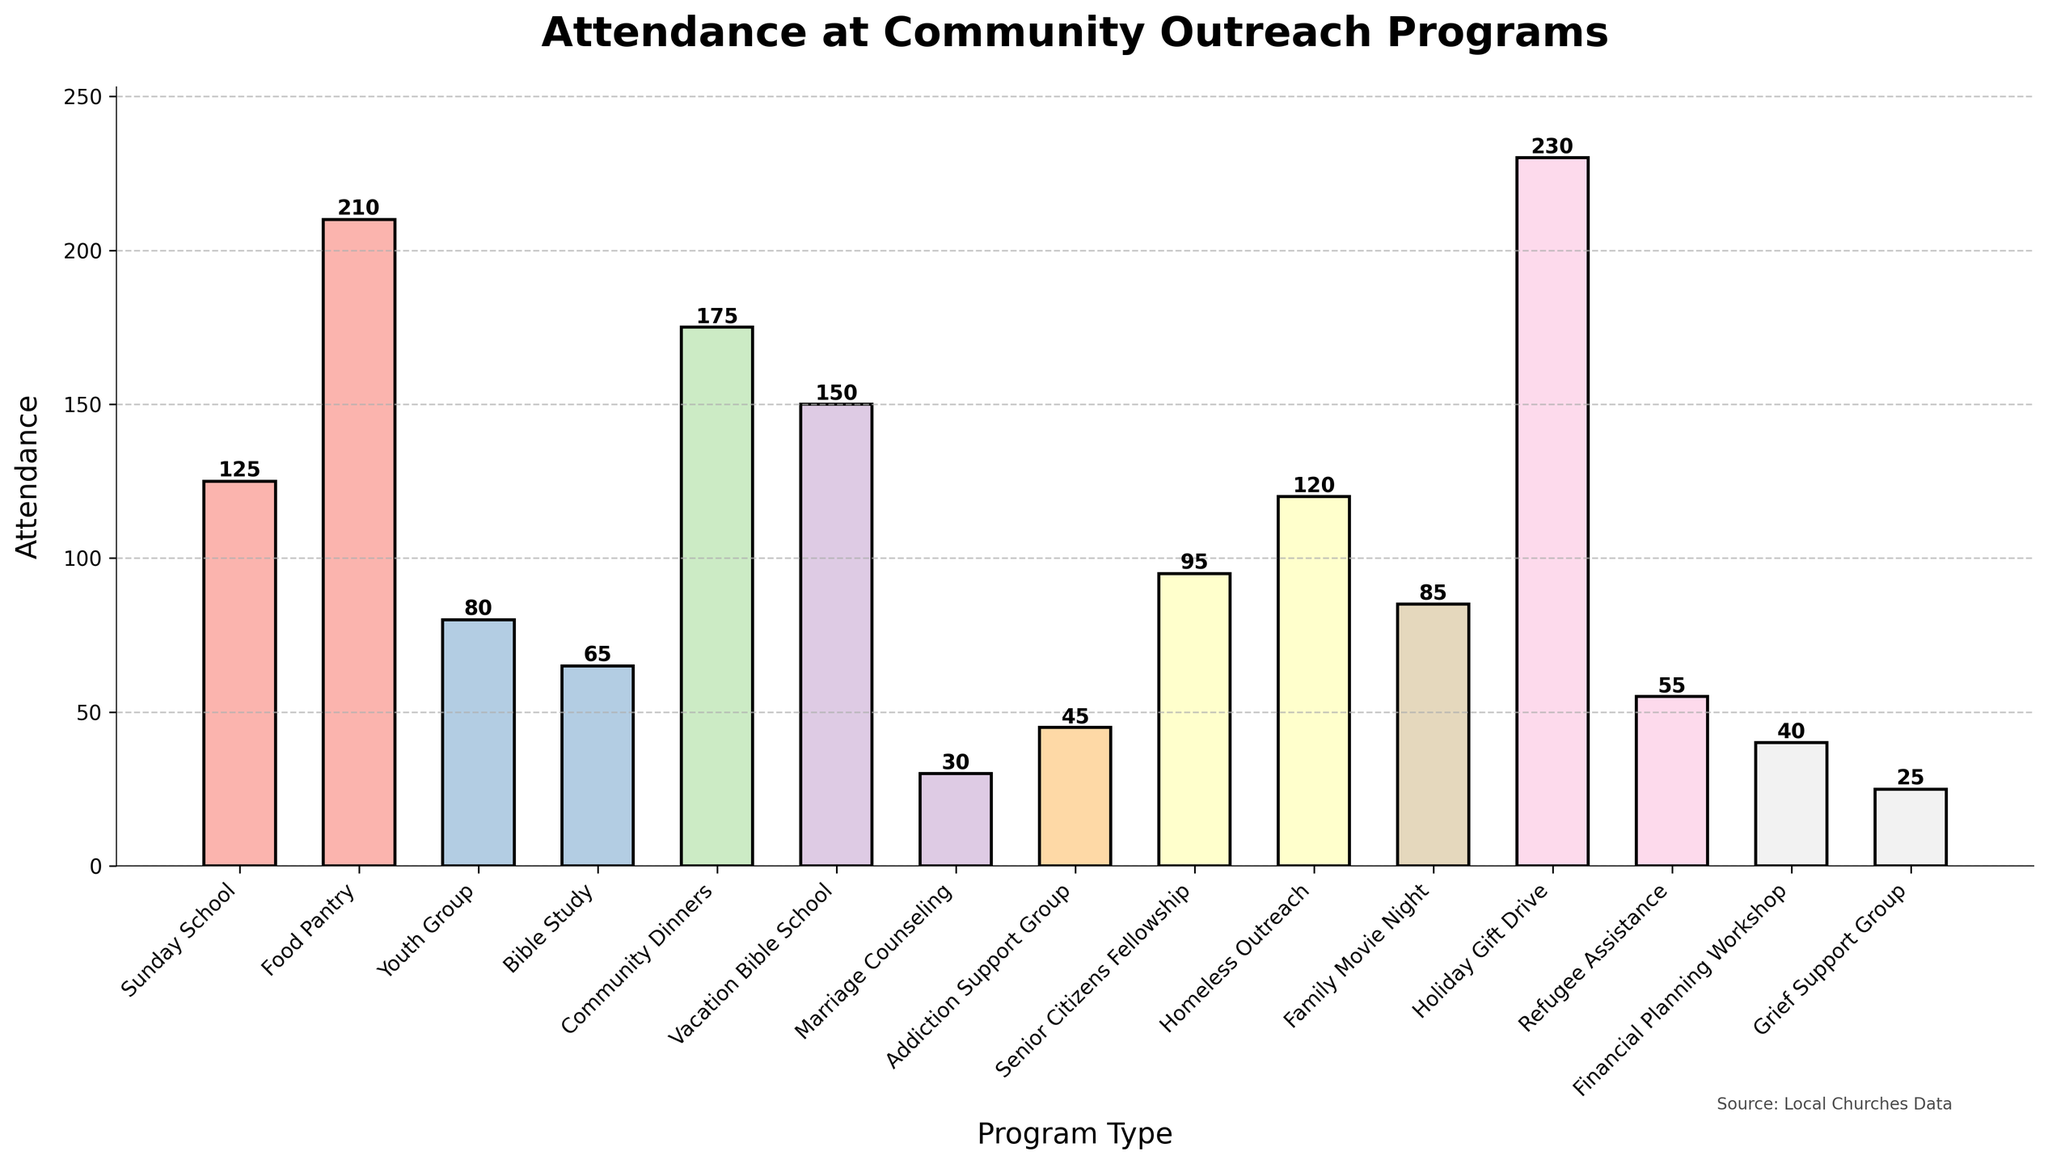Which program type has the highest attendance? Look at the heights of the bars. The highest bar represents the program type with the highest attendance.
Answer: Holiday Gift Drive How many people attended both Sunday School and Vacation Bible School? Add the attendance numbers of Sunday School and Vacation Bible School. 125 (Sunday School) + 150 (Vacation Bible School) = 275
Answer: 275 Which program type has lower attendance, Marriage Counseling or Financial Planning Workshop? Compare the heights of the bars. Marriage Counseling has an attendance of 30 and Financial Planning Workshop has an attendance of 40.
Answer: Marriage Counseling What is the difference in attendance between Community Dinners and Youth Group? Subtract the attendance number of Youth Group from Community Dinners. 175 (Community Dinners) - 80 (Youth Group) = 95
Answer: 95 Is attendance at Grief Support Group higher than Refugee Assistance? Compare the heights of the bars. Grief Support Group has an attendance of 25 and Refugee Assistance has an attendance of 55.
Answer: No Which three programs have the lowest attendance? Identify the three shortest bars on the chart. Grief Support Group, Marriage Counseling, and Addiction Support Group have the lowest attendance.
Answer: Grief Support Group, Marriage Counseling, Addiction Support Group How much more is the attendance at Food Pantry compared to Bible Study? Subtract the attendance number of Bible Study from Food Pantry. 210 (Food Pantry) - 65 (Bible Study) = 145
Answer: 145 What is the combined attendance of all the support groups (Addiction Support Group and Grief Support Group)? Add the attendance numbers of Addiction Support Group and Grief Support Group. 45 (Addiction Support Group) + 25 (Grief Support Group) = 70
Answer: 70 Which has greater attendance: Holiday Gift Drive or the sum of Sunday School and Youth Group? First, find the sum of Sunday School and Youth Group attendance. Then compare it to Holiday Gift Drive. 125 (Sunday School) + 80 (Youth Group) = 205. Holiday Gift Drive has 230.
Answer: Holiday Gift Drive What is the total attendance of programs with more than 100 attendees? Identify programs with attendance above 100 and sum their attendance numbers. Programs: Sunday School (125), Food Pantry (210), Community Dinners (175), Vacation Bible School (150), Holiday Gift Drive (230), Homeless Outreach (120). Total = 125 + 210 + 175 + 150 + 230 + 120 = 1010.
Answer: 1010 